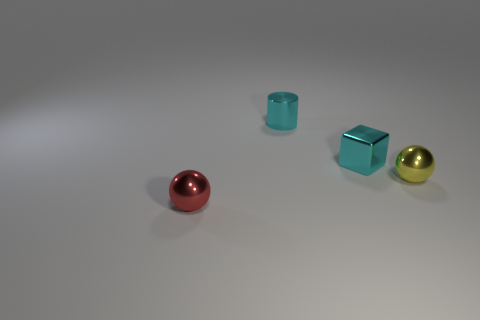Add 2 big blue matte objects. How many objects exist? 6 Subtract all yellow spheres. How many spheres are left? 1 Subtract all cubes. How many objects are left? 3 Subtract all red balls. Subtract all cyan cylinders. How many balls are left? 1 Subtract all yellow cubes. How many red balls are left? 1 Subtract all red rubber blocks. Subtract all cyan cubes. How many objects are left? 3 Add 2 tiny metallic cubes. How many tiny metallic cubes are left? 3 Add 4 small cyan metal cubes. How many small cyan metal cubes exist? 5 Subtract 0 purple cylinders. How many objects are left? 4 